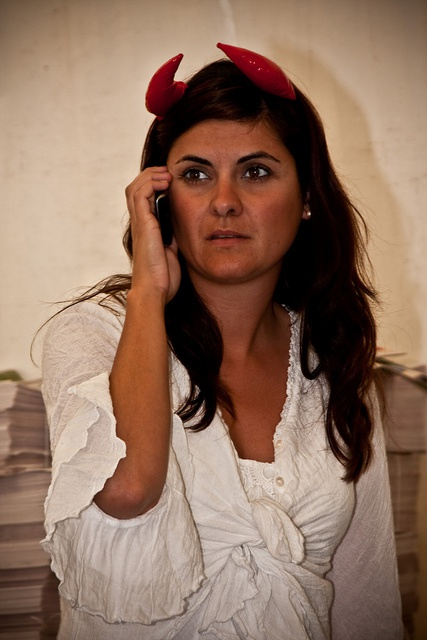Describe the objects in this image and their specific colors. I can see people in maroon, black, tan, and darkgray tones, couch in maroon, brown, and gray tones, and cell phone in maroon, black, gray, and olive tones in this image. 